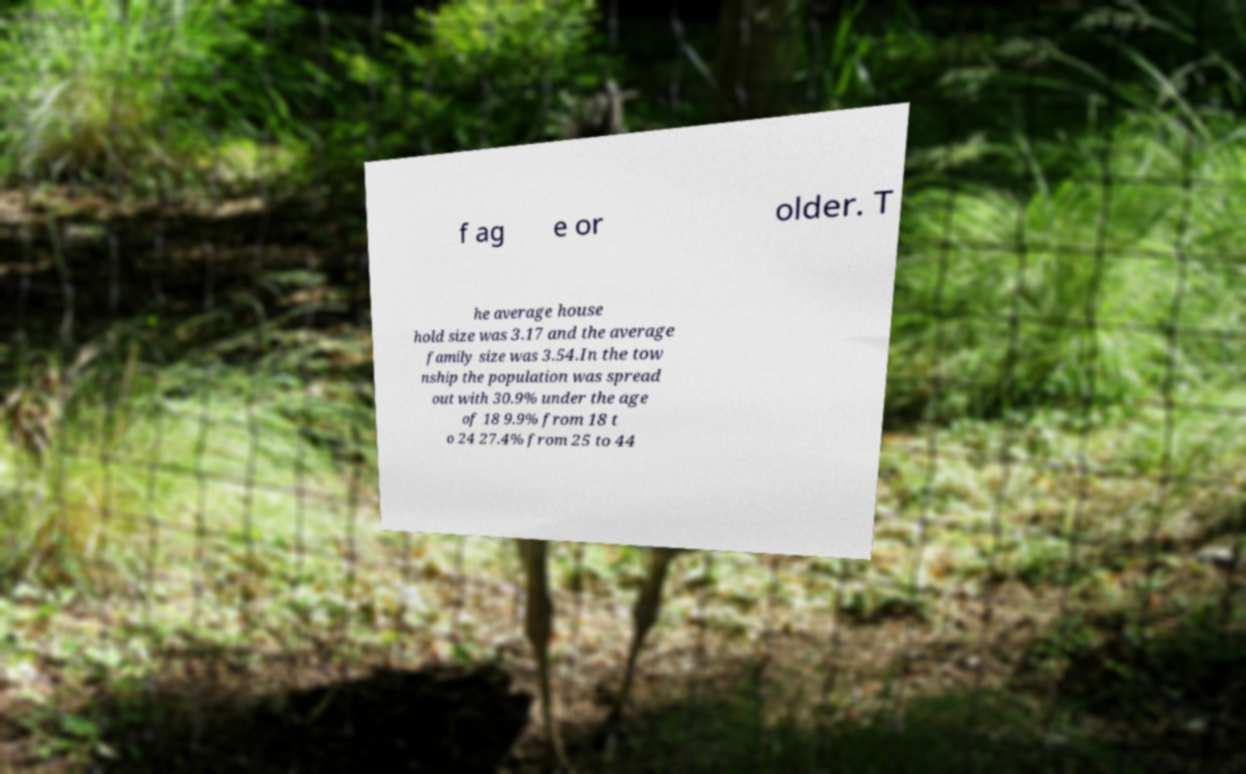Could you extract and type out the text from this image? f ag e or older. T he average house hold size was 3.17 and the average family size was 3.54.In the tow nship the population was spread out with 30.9% under the age of 18 9.9% from 18 t o 24 27.4% from 25 to 44 